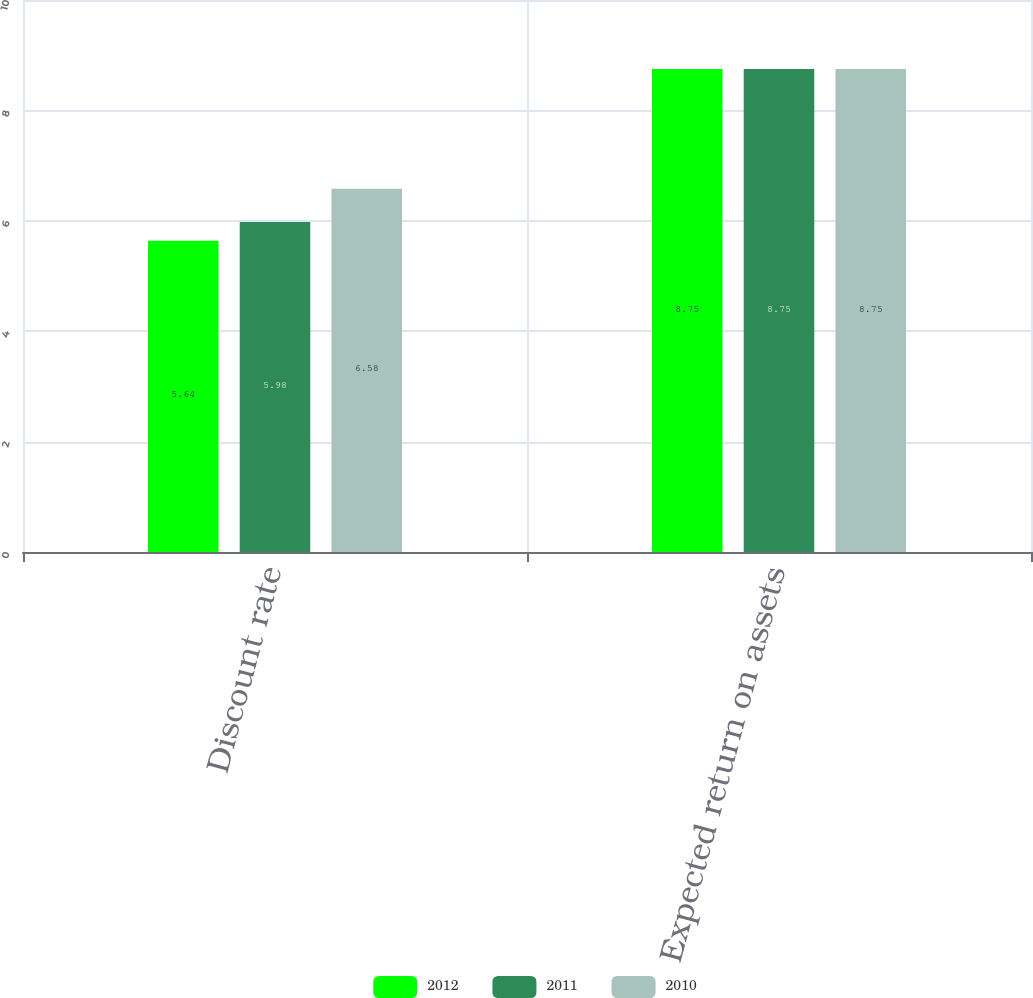<chart> <loc_0><loc_0><loc_500><loc_500><stacked_bar_chart><ecel><fcel>Discount rate<fcel>Expected return on assets<nl><fcel>2012<fcel>5.64<fcel>8.75<nl><fcel>2011<fcel>5.98<fcel>8.75<nl><fcel>2010<fcel>6.58<fcel>8.75<nl></chart> 